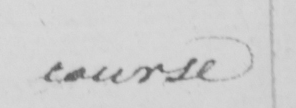Can you tell me what this handwritten text says? course 